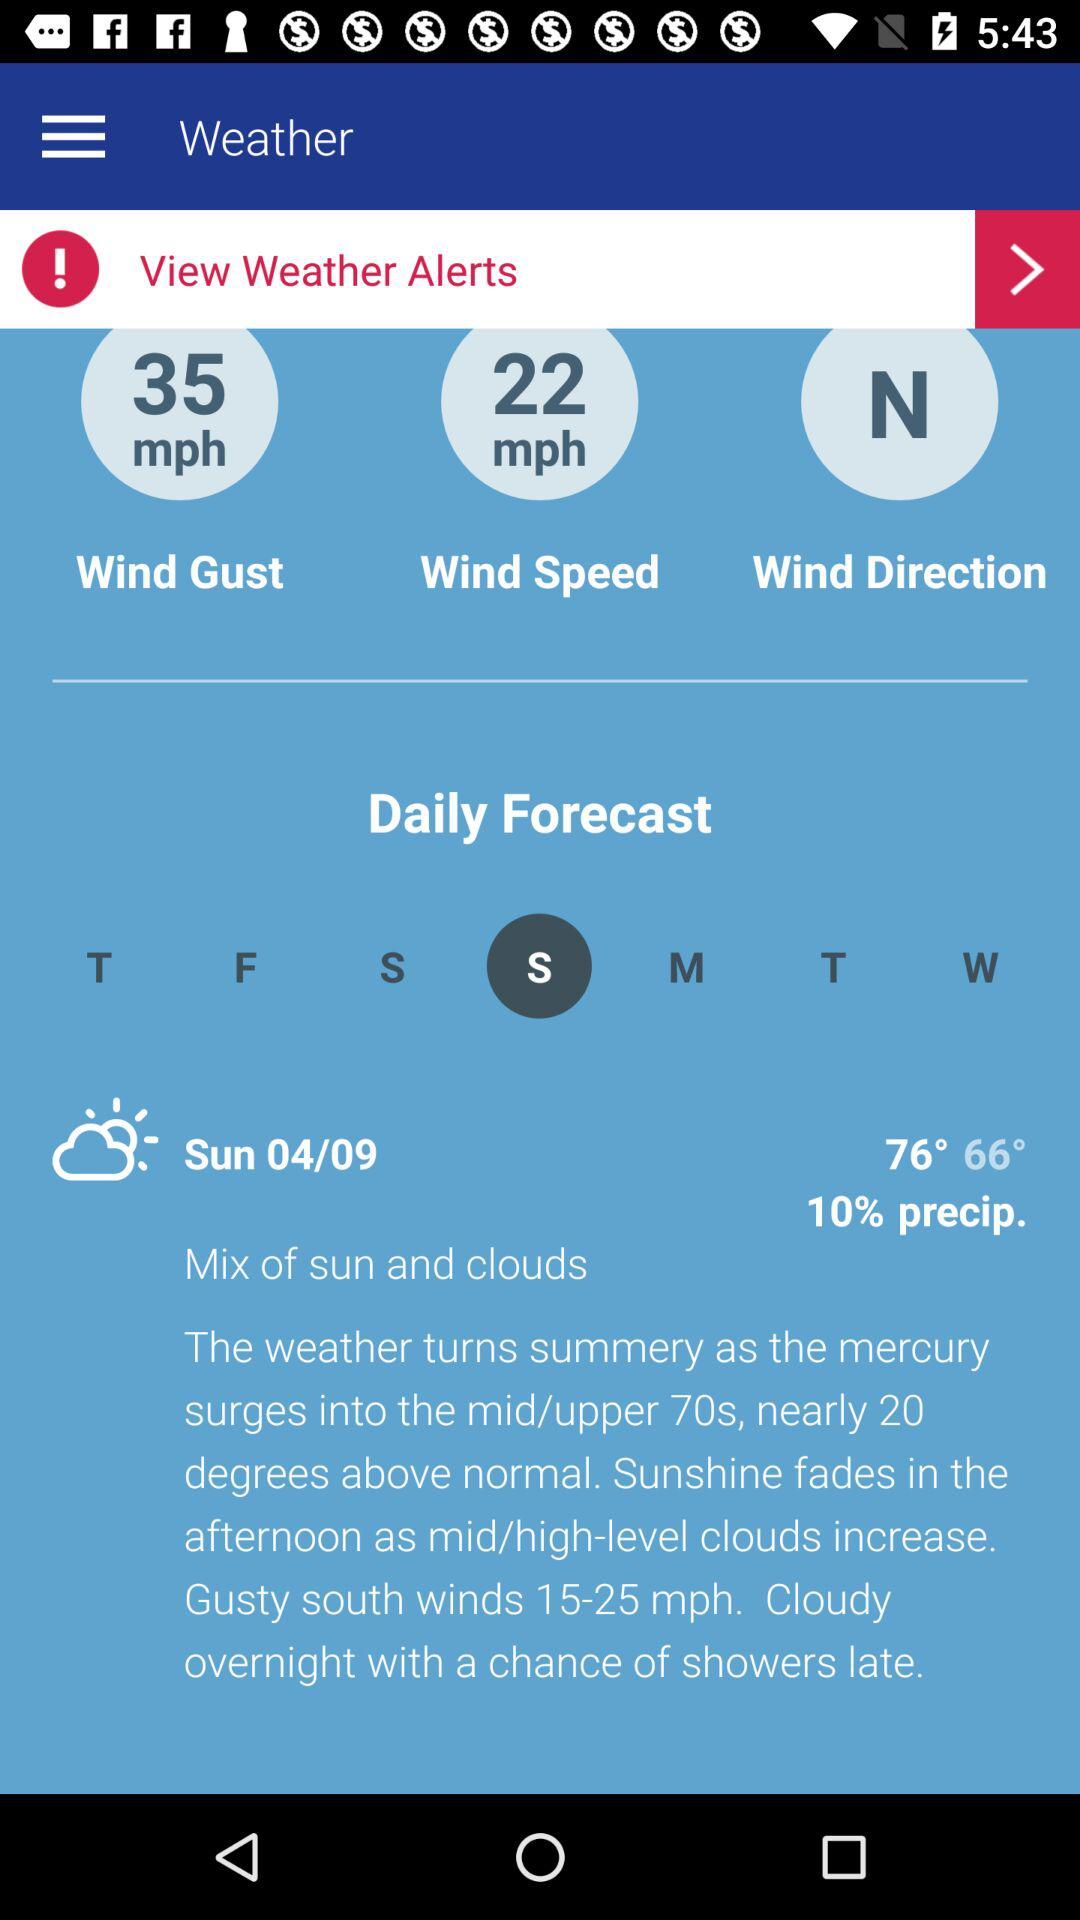What is the temperature on Monday?
When the provided information is insufficient, respond with <no answer>. <no answer> 